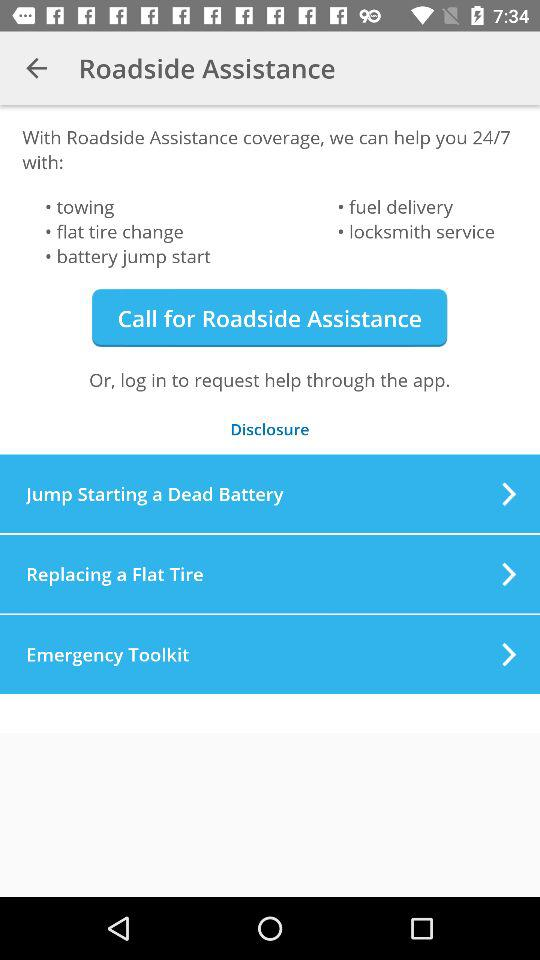With which things does the roadside assistance coverage help? The roadside assistance coverage helps with towing, flat tire changes, battery jump starts, fuel delivery and locksmith service. 